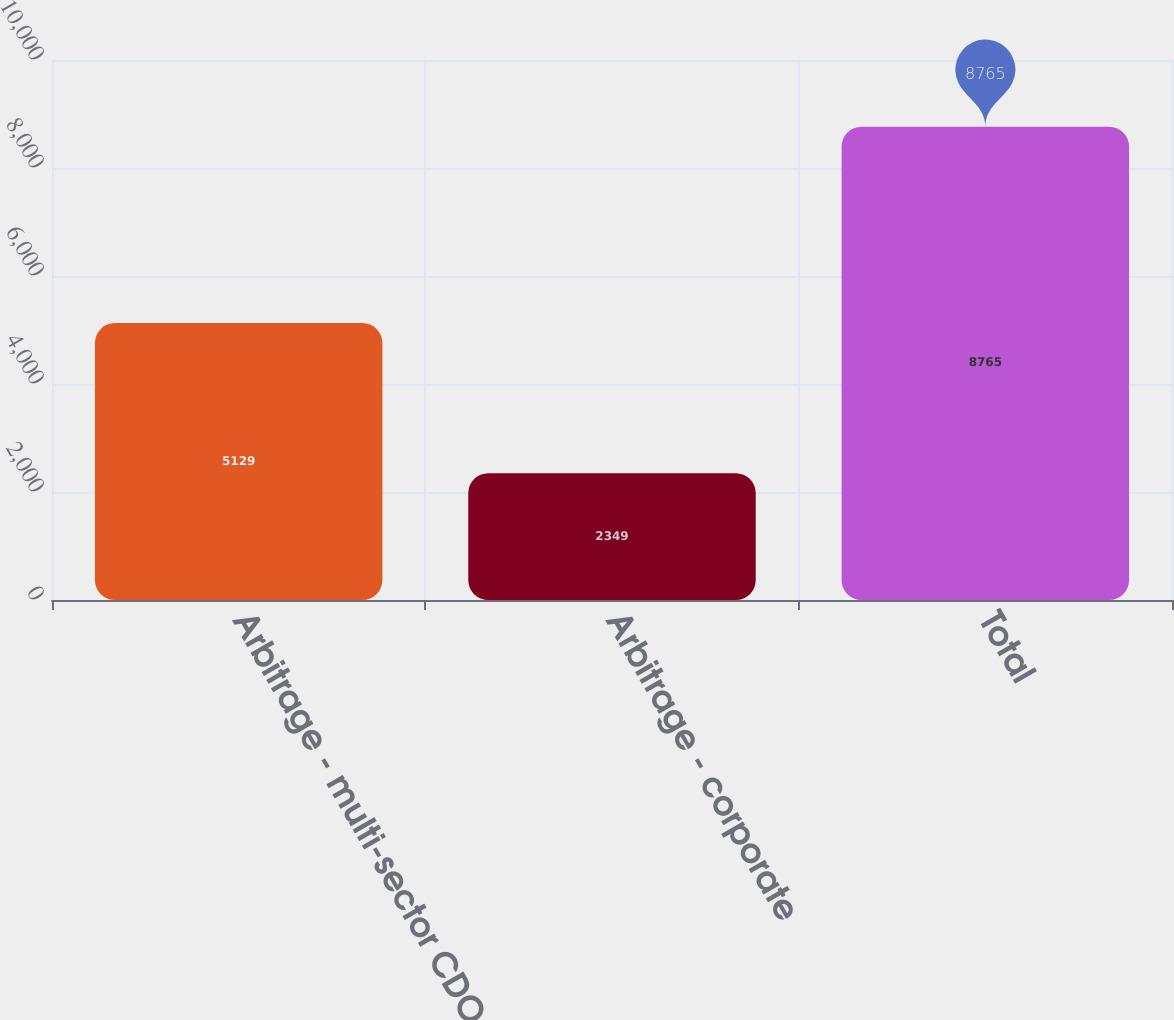Convert chart to OTSL. <chart><loc_0><loc_0><loc_500><loc_500><bar_chart><fcel>Arbitrage - multi-sector CDO<fcel>Arbitrage - corporate<fcel>Total<nl><fcel>5129<fcel>2349<fcel>8765<nl></chart> 